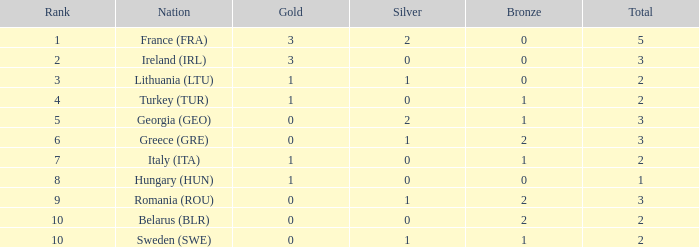What's the overall total when gold is negative and silver is less than 1? None. 